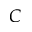Convert formula to latex. <formula><loc_0><loc_0><loc_500><loc_500>C</formula> 